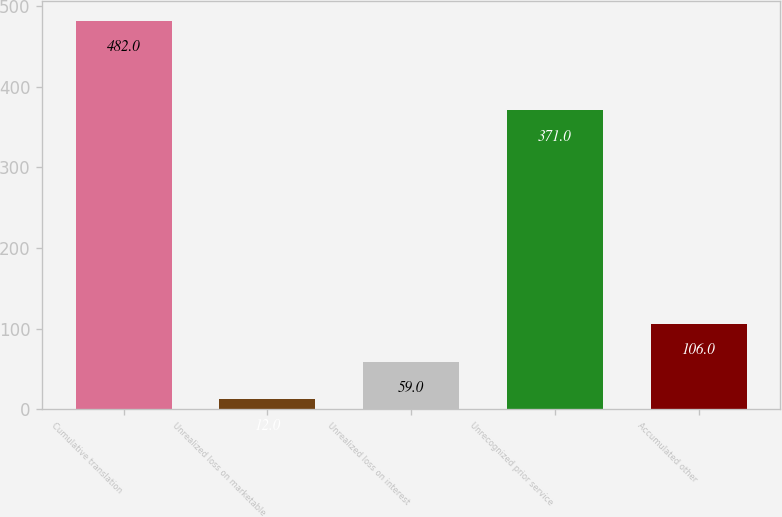Convert chart to OTSL. <chart><loc_0><loc_0><loc_500><loc_500><bar_chart><fcel>Cumulative translation<fcel>Unrealized loss on marketable<fcel>Unrealized loss on interest<fcel>Unrecognized prior service<fcel>Accumulated other<nl><fcel>482<fcel>12<fcel>59<fcel>371<fcel>106<nl></chart> 